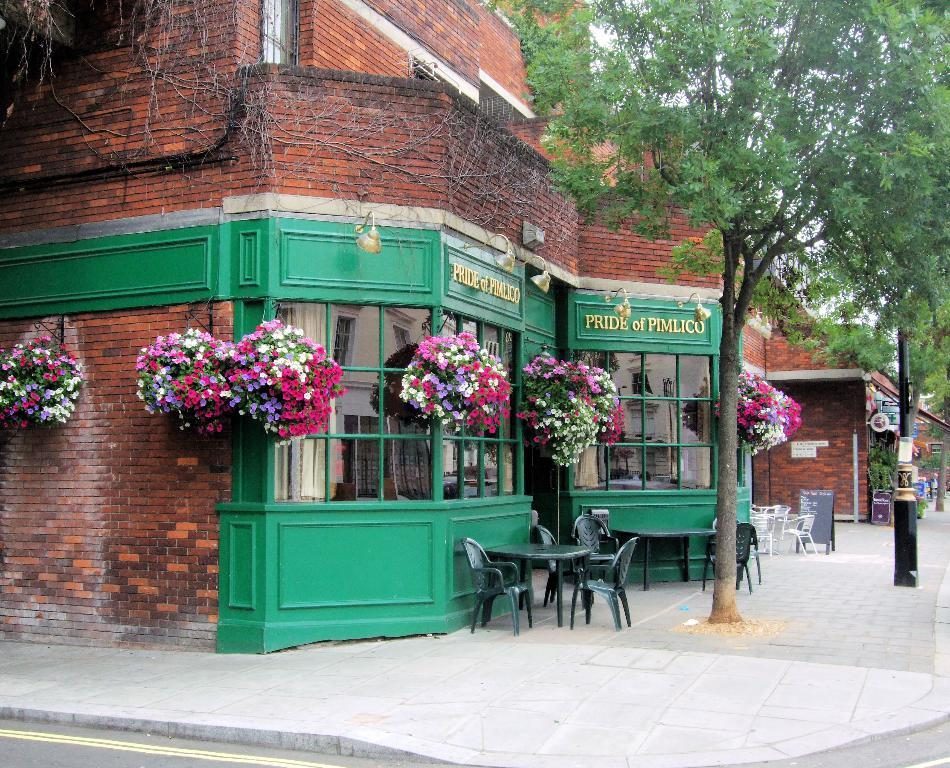What type of structure is visible in the image? There is a building in the image. What is written or displayed on the building? There is text on the building. What type of decorative items can be seen in the image? There are flower pots in the image. What type of vegetation is present in the image? There are trees in the image. What type of furniture is visible in the image? There are chairs and tables in the image. What type of surface is at the bottom of the image? There is a road at the bottom of the image, and there is also a pavement in the image. What role does the queen play in the image? There is no queen present in the image, so it is not possible to determine her role. 